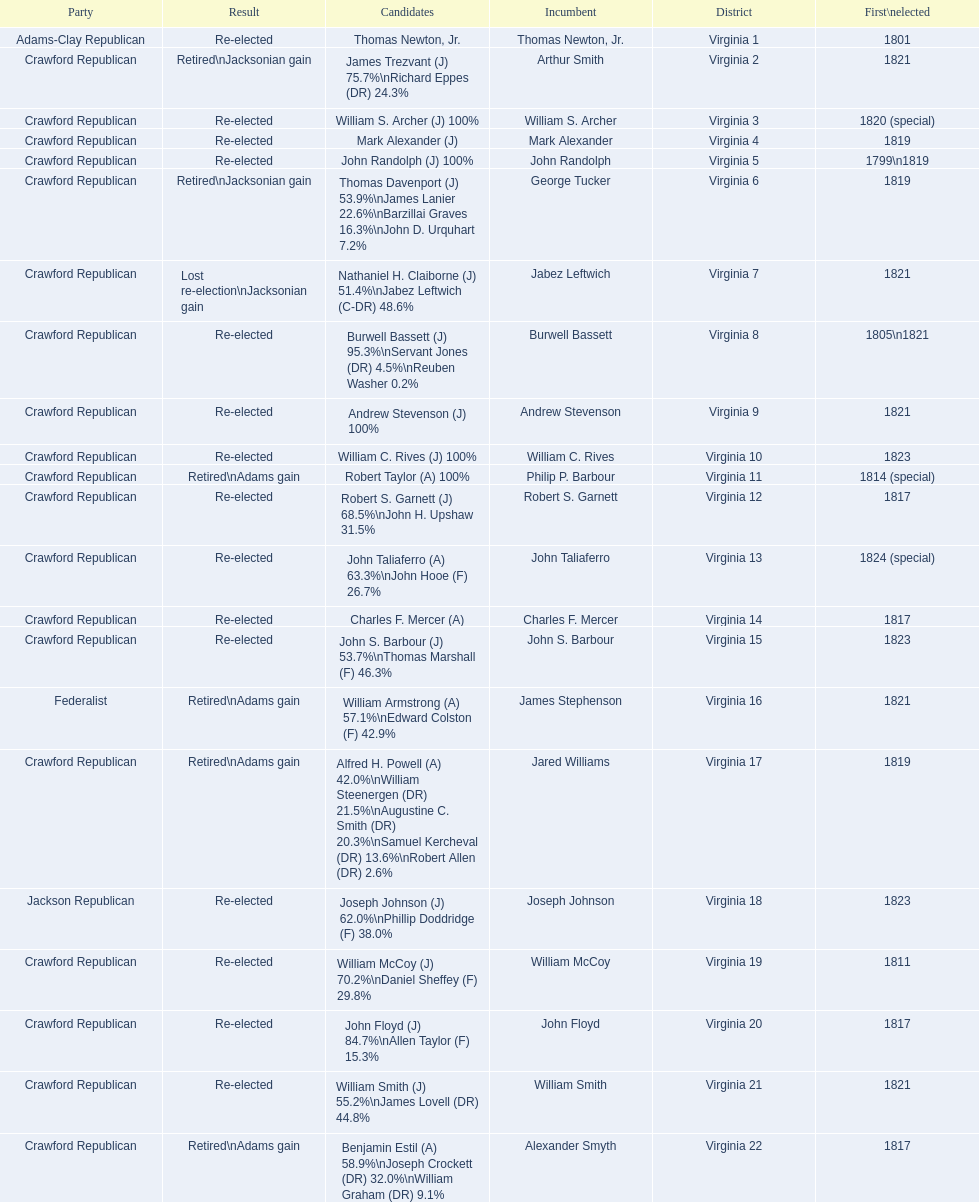What are the number of times re-elected is listed as the result? 15. 